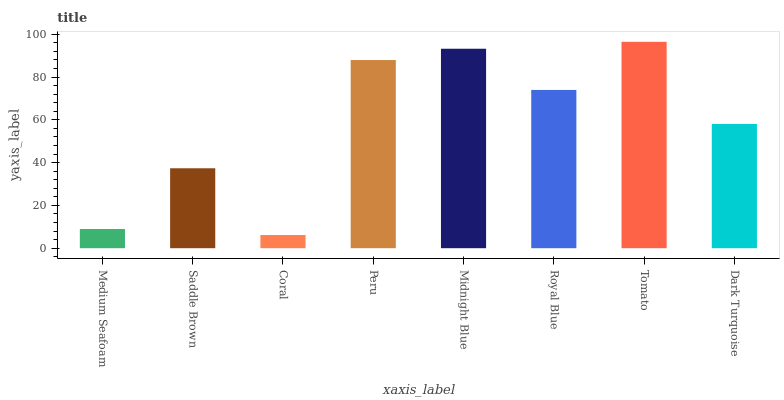Is Coral the minimum?
Answer yes or no. Yes. Is Tomato the maximum?
Answer yes or no. Yes. Is Saddle Brown the minimum?
Answer yes or no. No. Is Saddle Brown the maximum?
Answer yes or no. No. Is Saddle Brown greater than Medium Seafoam?
Answer yes or no. Yes. Is Medium Seafoam less than Saddle Brown?
Answer yes or no. Yes. Is Medium Seafoam greater than Saddle Brown?
Answer yes or no. No. Is Saddle Brown less than Medium Seafoam?
Answer yes or no. No. Is Royal Blue the high median?
Answer yes or no. Yes. Is Dark Turquoise the low median?
Answer yes or no. Yes. Is Peru the high median?
Answer yes or no. No. Is Royal Blue the low median?
Answer yes or no. No. 